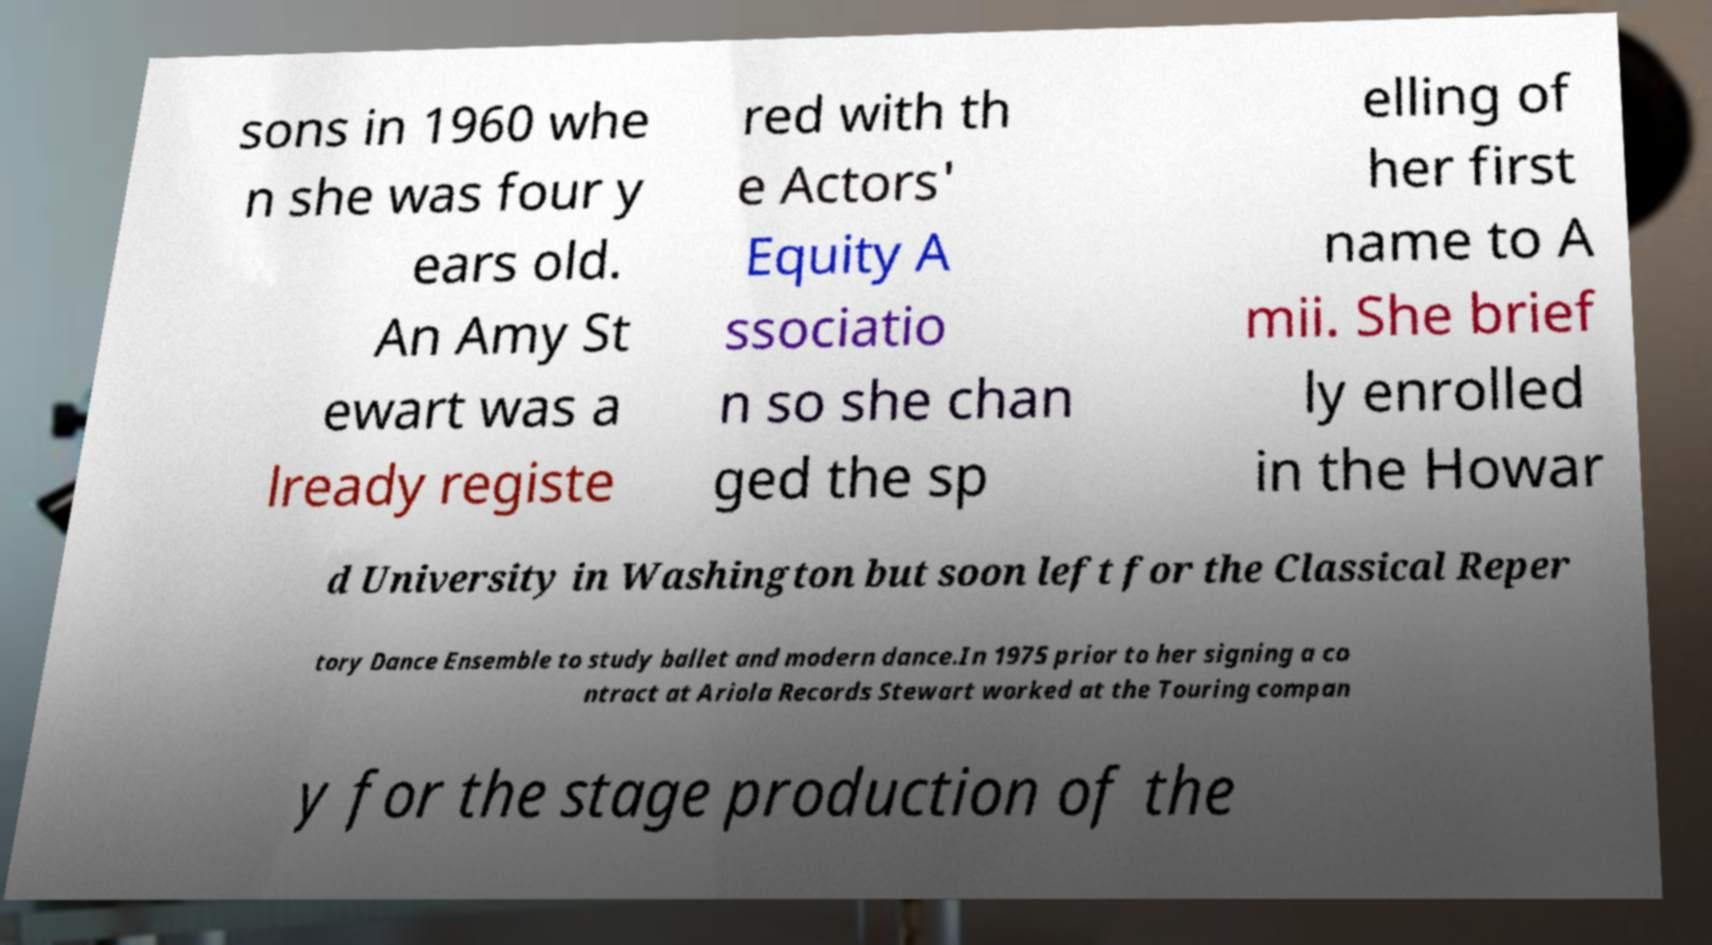Can you read and provide the text displayed in the image?This photo seems to have some interesting text. Can you extract and type it out for me? sons in 1960 whe n she was four y ears old. An Amy St ewart was a lready registe red with th e Actors' Equity A ssociatio n so she chan ged the sp elling of her first name to A mii. She brief ly enrolled in the Howar d University in Washington but soon left for the Classical Reper tory Dance Ensemble to study ballet and modern dance.In 1975 prior to her signing a co ntract at Ariola Records Stewart worked at the Touring compan y for the stage production of the 